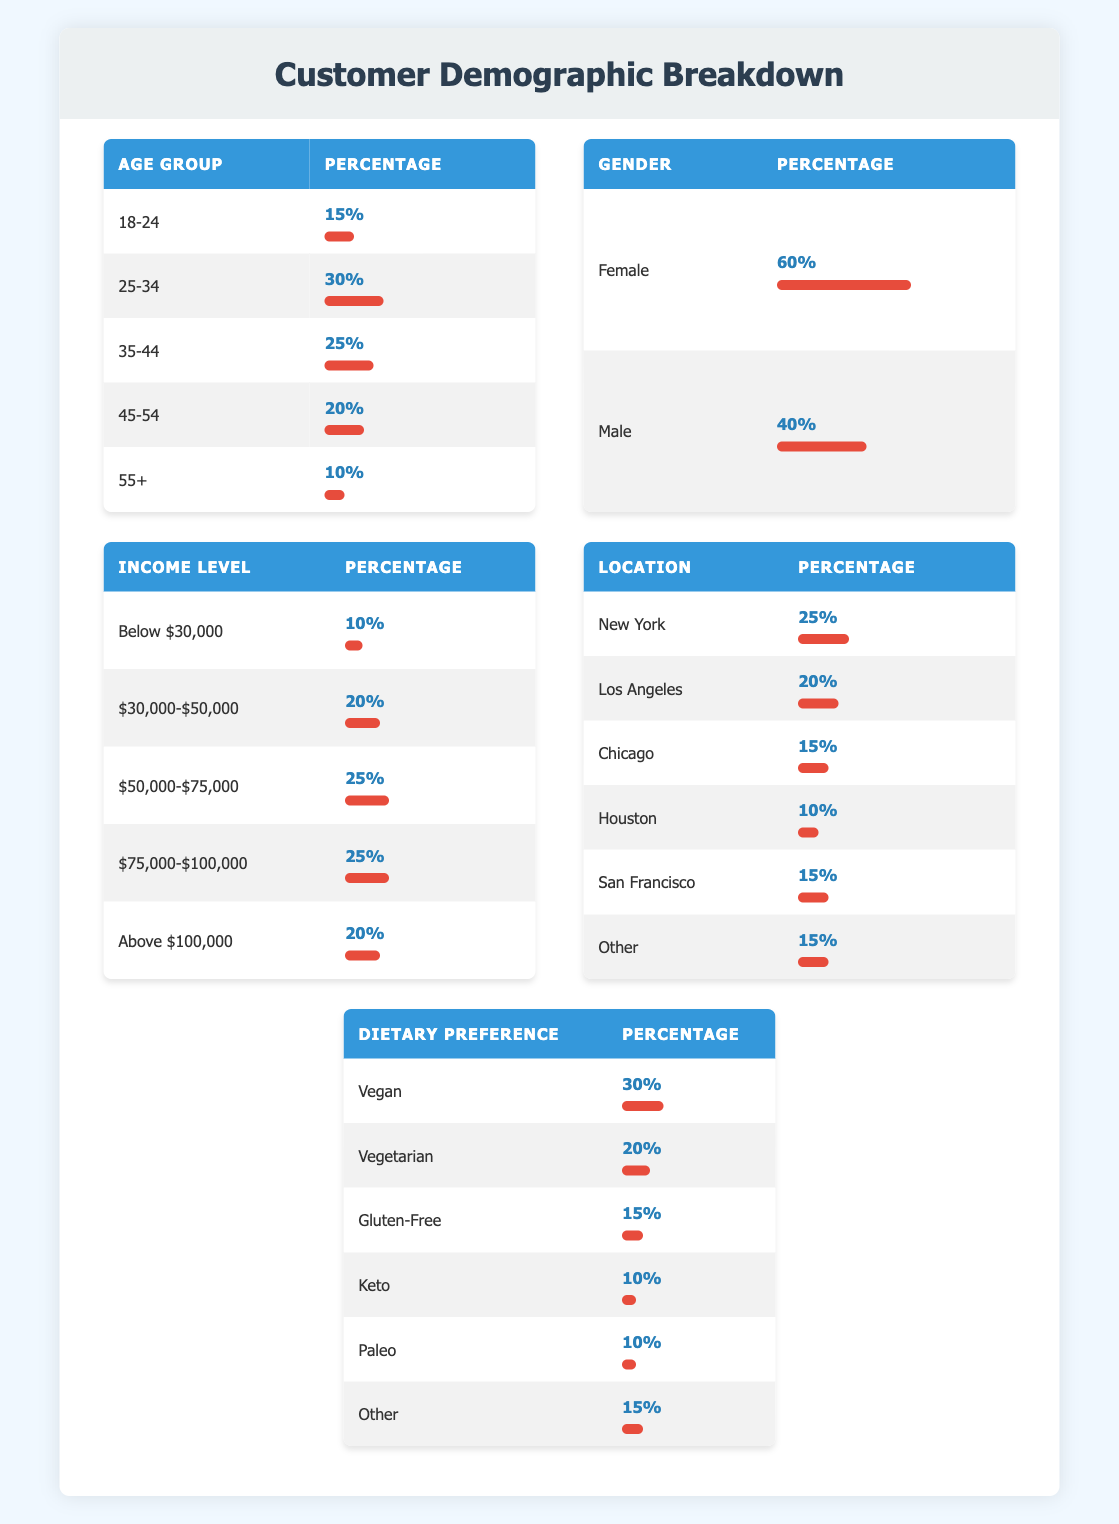What percentage of subscribers are aged 45-54? The table shows that the percentage of subscribers aged 45-54 is listed as 20%.
Answer: 20% Which gender has a higher subscriber percentage? According to the table, 60% of the subscribers are female while 40% are male. Therefore, female subscribers have a higher percentage.
Answer: Female What is the average percentage of subscribers in the age groups 18-24 and 55+? The percentages for the age groups 18-24 and 55+ are 15% and 10%, respectively. To find the average: (15 + 10) / 2 = 12.5%.
Answer: 12.5% Is the percentage of subscribers with an income above $75,000 greater than those below $50,000? The table shows that 25% of subscribers have an income above $75,000, while only 20% have an income below $50,000. Therefore, yes, the percentage above $75,000 is greater.
Answer: Yes What percentage of subscribers prefer vegan or vegetarian diets? The table indicates that 30% of subscribers prefer vegan diets and 20% prefer vegetarian diets. To find the total, we sum these percentages: 30 + 20 = 50%.
Answer: 50% Which city has the lowest percentage of subscribers? The table lists Houston with a percentage of 10%, which is lower than all other cities listed.
Answer: Houston If we combine the percentages of subscribers aged 25-34 and 35-44, what will the total percentage be? The percentages for the age groups 25-34 and 35-44 are 30% and 25%, respectively. Adding these gives us: 30 + 25 = 55%.
Answer: 55% How many percentage points more do subscribers aged 25-34 have compared to those aged 55+? Subscribers aged 25-34 make up 30%, whereas those aged 55+ account for 10%. The difference is calculated as: 30 - 10 = 20 percentage points.
Answer: 20 percentage points Are vegan subscribers more than those who prefer keto and paleo combined? The table indicates that 30% prefer vegan, while 10% prefer keto and another 10% prefer paleo. Combined, keto and paleo account for 10 + 10 = 20%, which is less than vegan's 30%. Thus, yes, vegan subscribers are more.
Answer: Yes 